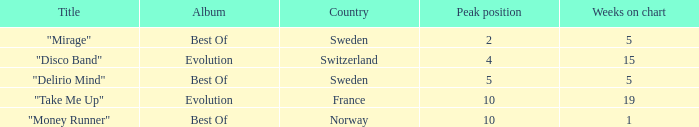What is the country with the album best of and weeks on chart is less than 5? Norway. 